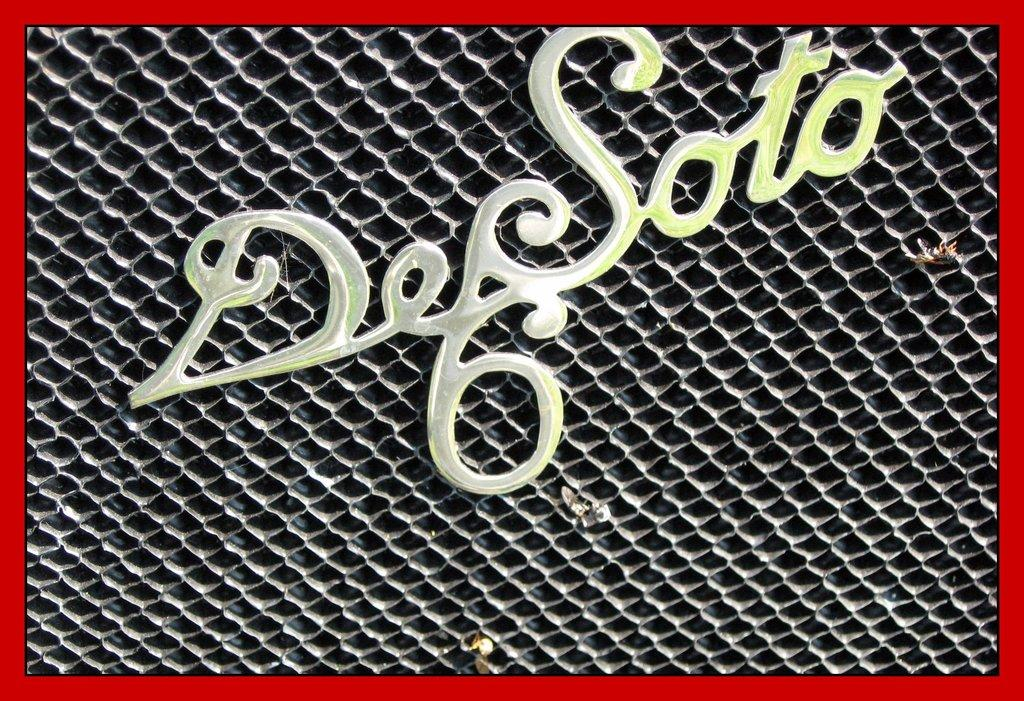What can be seen on the object in the image? There is text on an object in the image. How many feet are visible on the object in the image? There are no feet visible on the object in the image, as it only has text on it. What type of news can be seen on the object in the image? There is no news present on the object in the image; it only has text. 